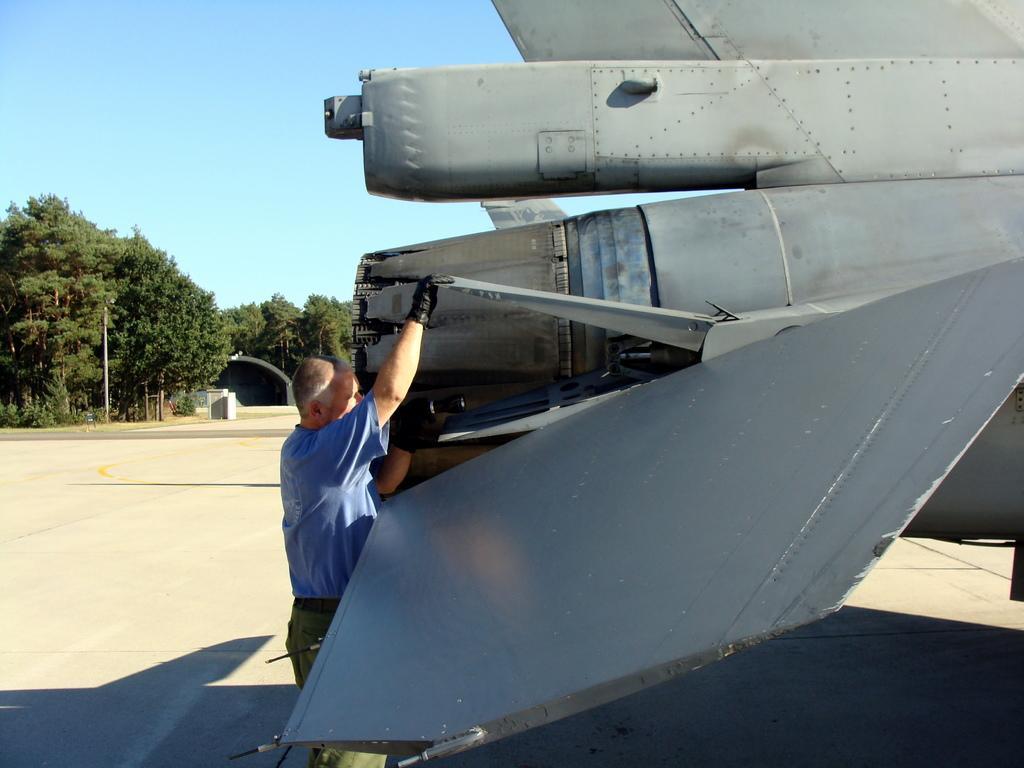In one or two sentences, can you explain what this image depicts? This picture is of outside. In the center there is a man wearing blue color t-shirt and standing on the ground. On the right there is a machine which seems to be an aircraft. In the background we can see the pole, trees and the sky. 